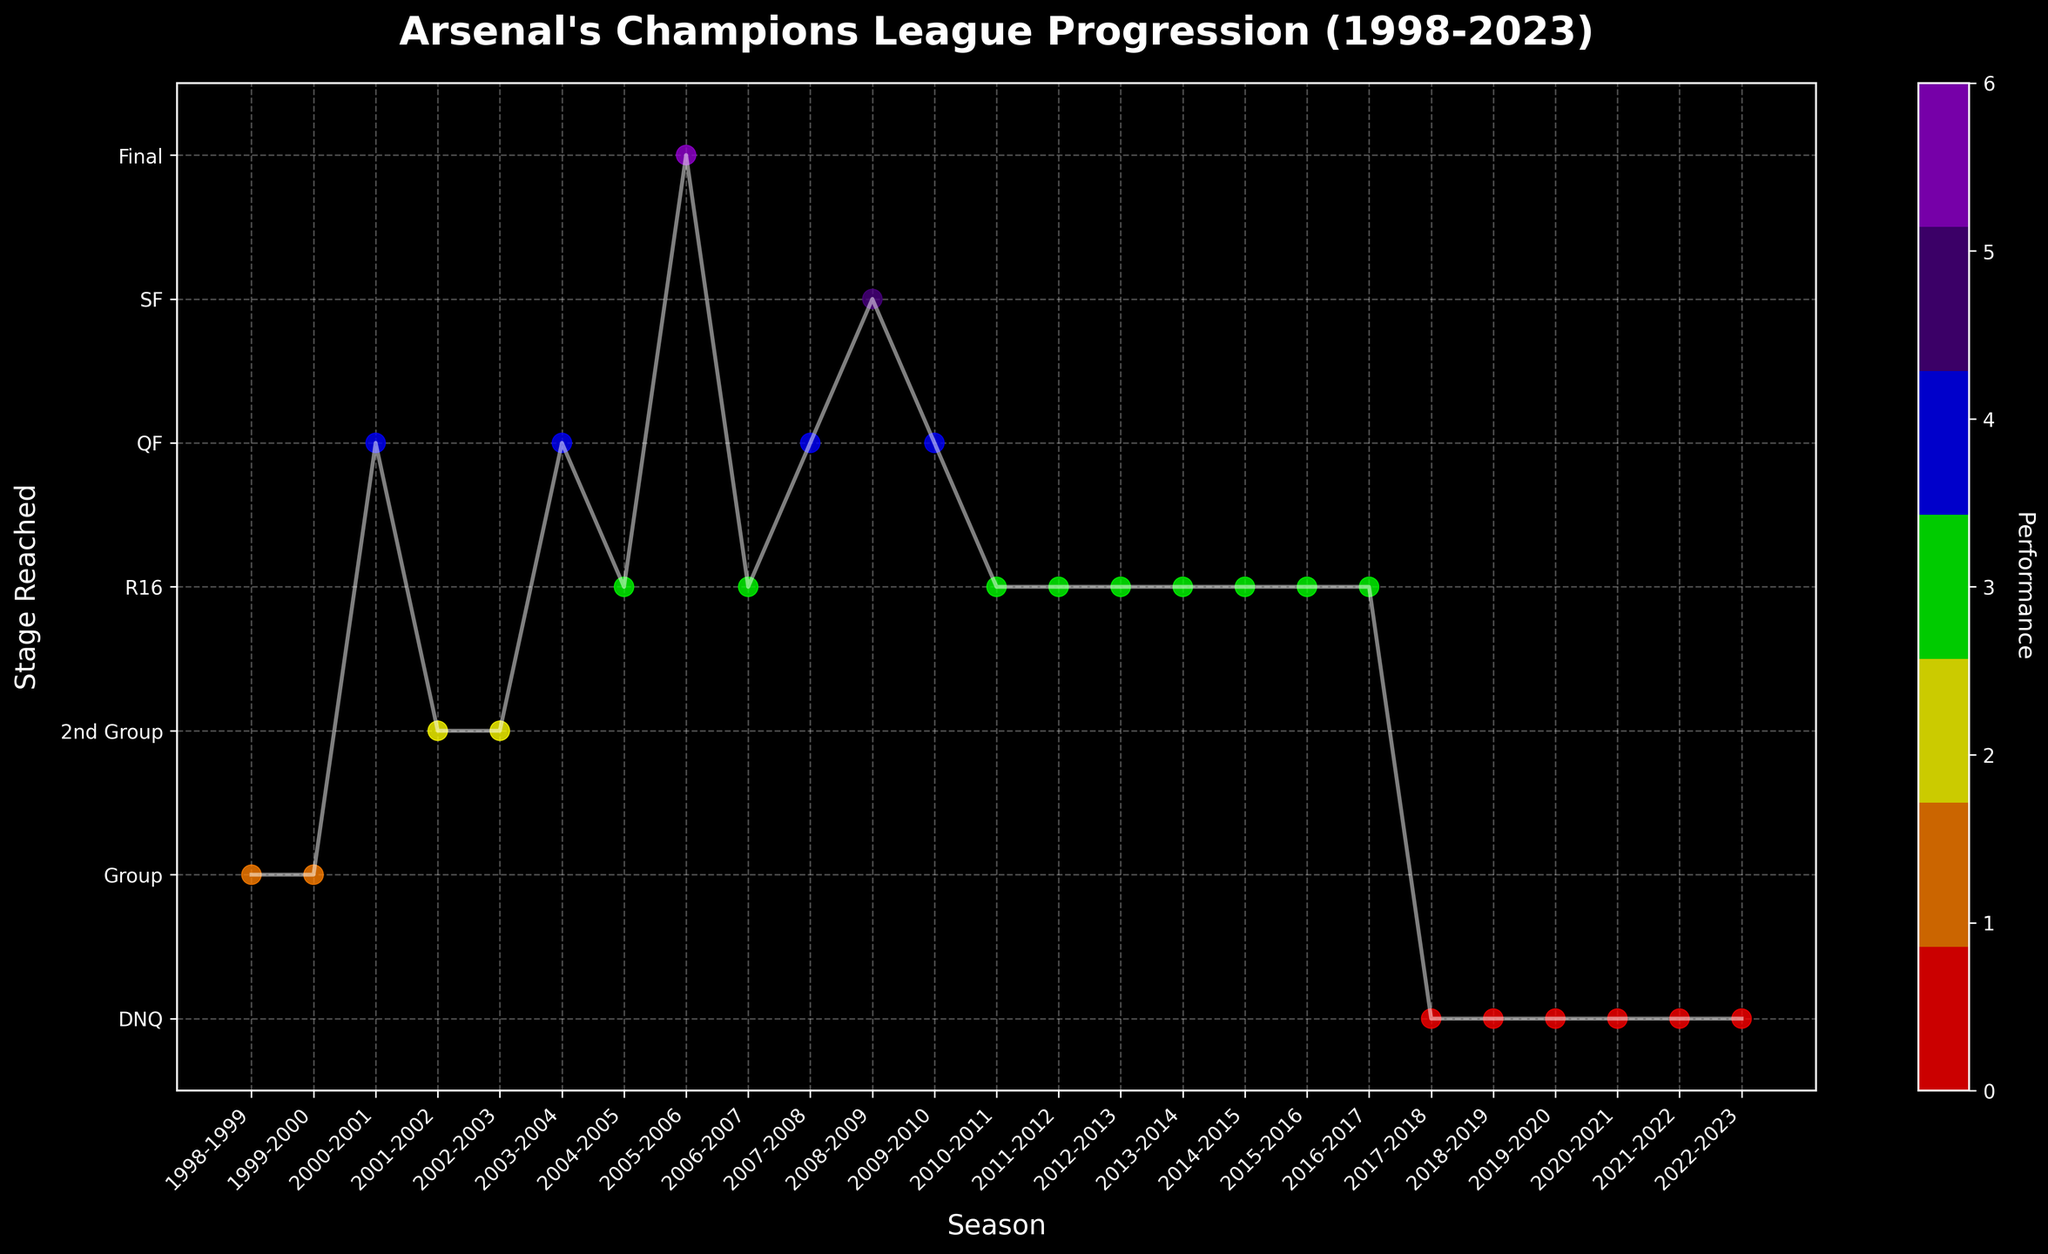When did Arsenal reach the final in the Champions League? To find this, look for the highest point in the chart, which represents the final. From this, trace down to the corresponding season.
Answer: 2005-2006 How many times did Arsenal reach the Round of 16 between 2010 and 2017? Identify the Round of 16 position on the y-axis (labeled as "R16") and count the number of seasons within 2010-2017 that align with this stage. The relevant seasons are 2010-2011, 2011-2012, 2012-2013, 2013-2014, 2014-2015, 2015-2016, and 2016-2017.
Answer: 7 Which season did Arsenal have their best performance in the early 2000s? Look at the early 2000s seasons (2000 to 2005) and note the highest point of progression. The highest position is the quarter-finals.
Answer: 2000-2001 and 2003-2004 How many times did Arsenal fail to qualify for the Champions League in the last 8 seasons? Check the last 8 seasons on the x-axis and count the number of times the progression level is at the bottom, indicating "Did Not Qualify".
Answer: 6 Compare Arsenal's performance in the 1998-1999 and 1999-2000 seasons. Which season was better? Locate both seasons on the x-axis and compare their progression levels. Both seasons are at the same level (Group Stage) but reviewing might reveal something more like difference in results.
Answer: Both are Group Stage, same level Which season saw Arsenal reach the semi-finals? Look for the point closest to the penultimate highest level on the y-axis (labeled "SF") and trace it back to the x-axis for the corresponding season.
Answer: 2008-2009 What is the most common stage Arsenal reached between 2010 and 2016? Identify the stages from 2010 to 2016 and observe which stage appears most frequently. Most of these points align with the Round of 16.
Answer: Round of 16 Did Arsenal perform better in the early 2000s or the early 2010s? Compare the progression stages for the early 2000s (2000-2005) and the early 2010s (2010-2015). The stages in the early 2000s include two Quarter-finals, Second Group Stage, and Round of 16, while the early 2010s are mostly Round of 16s.
Answer: Early 2000s Between which seasons did Arsenal see the most significant drop in performance? Look for the largest vertical drop between two consecutive seasons, indicating the most significant drop in performance. The drop from the final in 2005-2006 to the Round of 16 in 2006-2007 stands out.
Answer: 2005-2006 to 2006-2007 